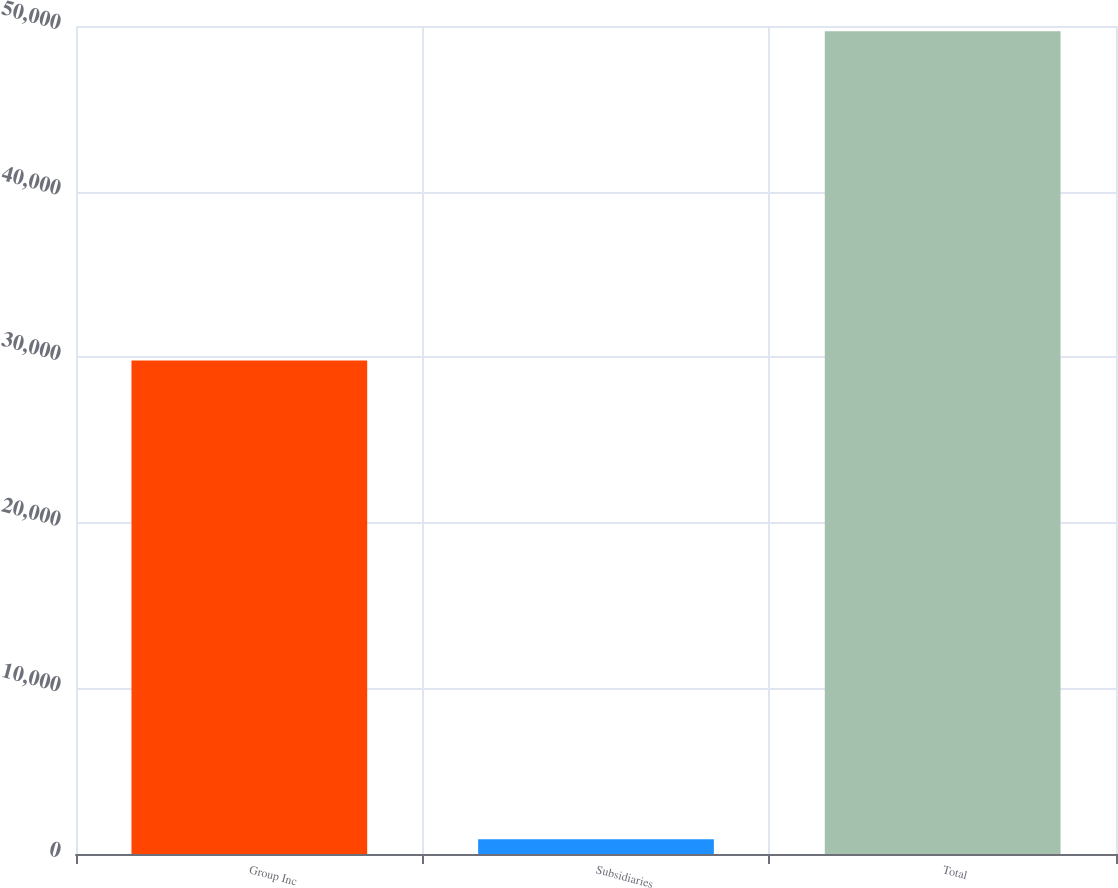Convert chart. <chart><loc_0><loc_0><loc_500><loc_500><bar_chart><fcel>Group Inc<fcel>Subsidiaries<fcel>Total<nl><fcel>29808<fcel>895<fcel>49689<nl></chart> 